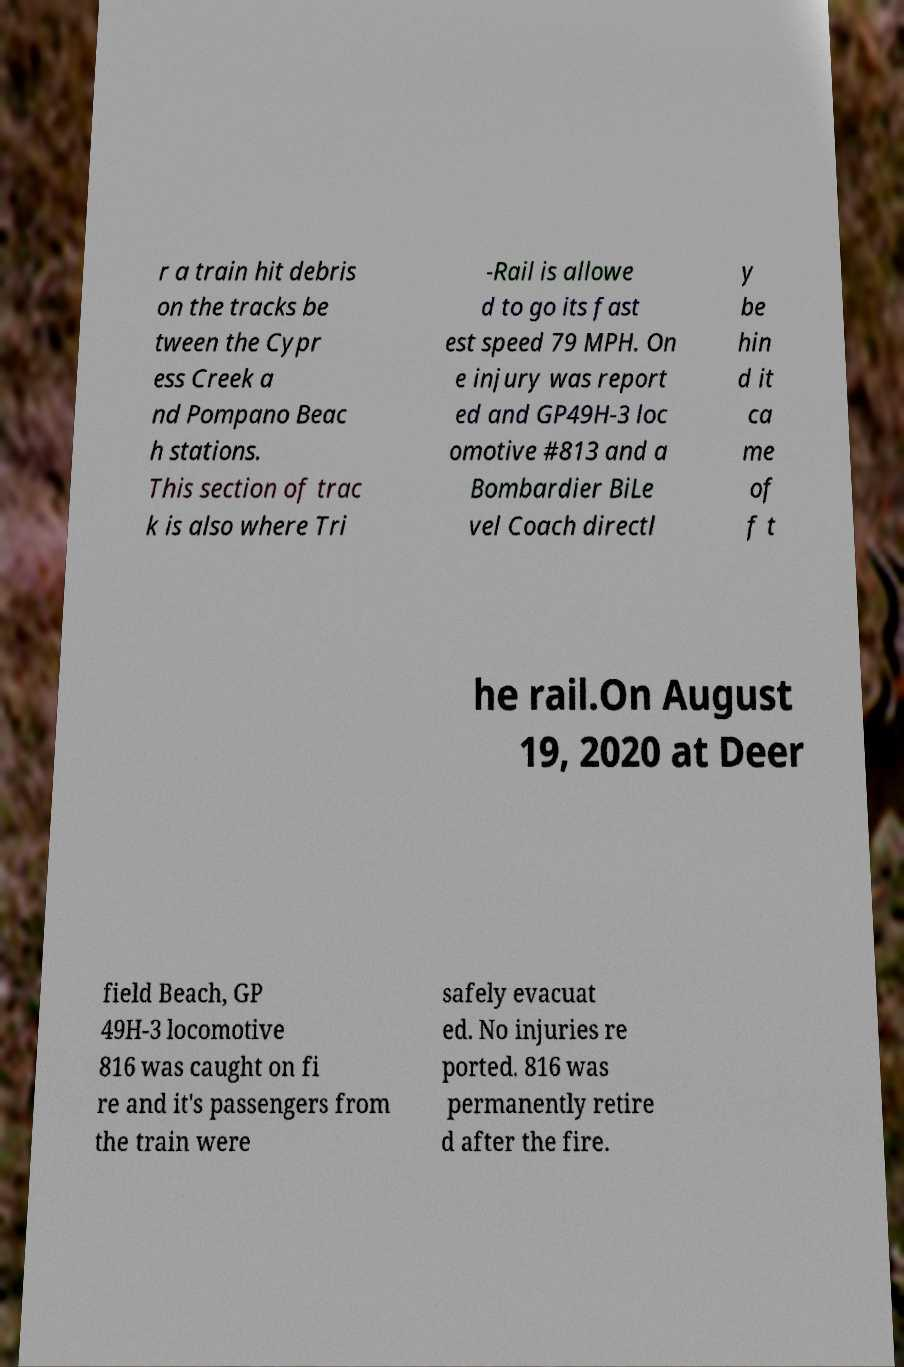Could you extract and type out the text from this image? r a train hit debris on the tracks be tween the Cypr ess Creek a nd Pompano Beac h stations. This section of trac k is also where Tri -Rail is allowe d to go its fast est speed 79 MPH. On e injury was report ed and GP49H-3 loc omotive #813 and a Bombardier BiLe vel Coach directl y be hin d it ca me of f t he rail.On August 19, 2020 at Deer field Beach, GP 49H-3 locomotive 816 was caught on fi re and it's passengers from the train were safely evacuat ed. No injuries re ported. 816 was permanently retire d after the fire. 